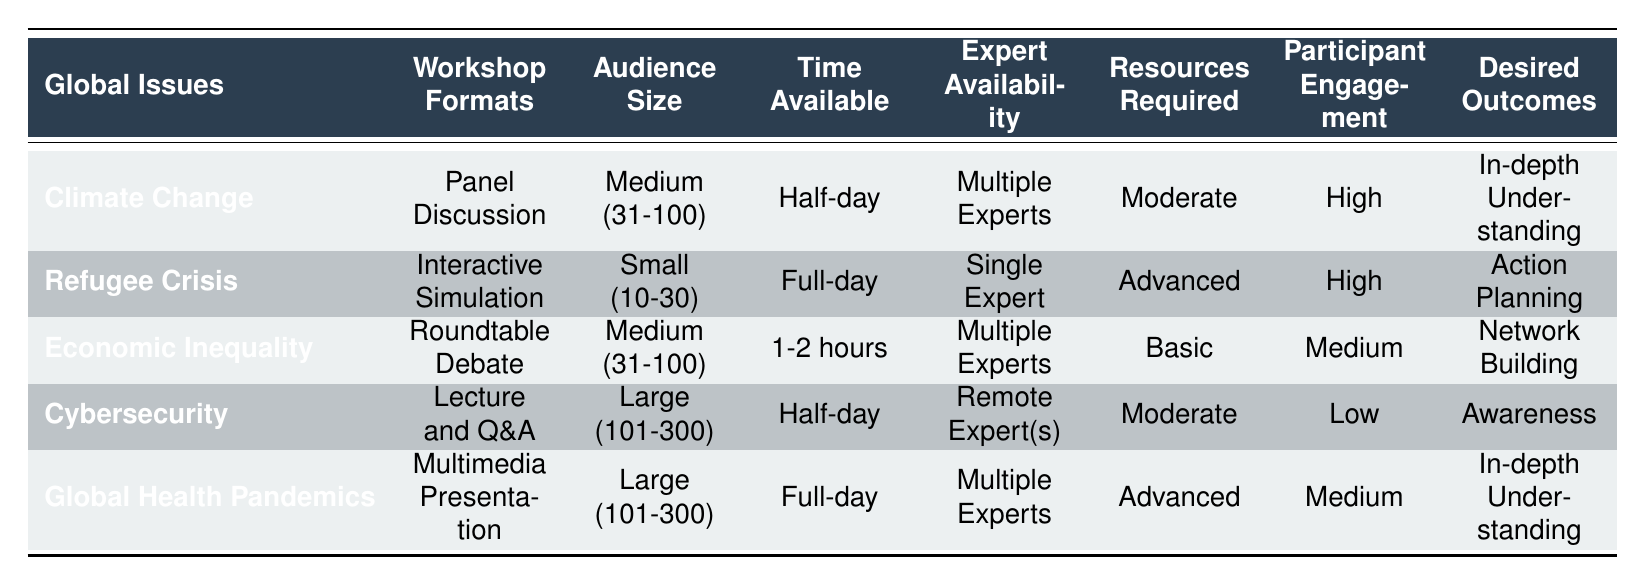What workshop format is recommended for addressing the Climate Change issue? The table indicates that the recommended workshop format for Climate Change is a Panel Discussion. This is found in the first row under the corresponding topic.
Answer: Panel Discussion Is the audience size for the Refugee Crisis workshop small, medium, or large? The Refugee Crisis workshop is designed for a small audience size, as noted in the table where it specifies "Small (10-30)" in the Audience Size column for this issue.
Answer: Small (10-30) Which global issue utilizes multiple experts and requires high participant engagement? By analyzing the rows, both Climate Change and Global Health Pandemics utilize multiple experts and have high participant engagement levels. The corresponding issues are Climate Change in the first row and Global Health Pandemics in the last row.
Answer: Climate Change and Global Health Pandemics Is the format for the Cybersecurity workshop an interactive simulation? The table states that the format for the Cybersecurity workshop is "Lecture and Q&A," which is a different type than an interactive simulation. This information can be directly checked in the row corresponding to Cybersecurity.
Answer: No What is the average expected audience size for workshops focused on Economic Inequality and Global Health Pandemics? The average audience size can be calculated by taking the audience sizes for Economic Inequality (Medium - 31-100) and Global Health Pandemics (Large - 101-300). We can convert "Medium" to an average of 65.5 and "Large" to an average of 200. Adding these yields 265. Dividing by 2 for the average gives us 132.5. Therefore, the average audience size for these two workshops is approximately 132.5.
Answer: 132.5 What are the desired outcomes for workshops on Economic Inequality and Cybersecurity? The desired outcome for Economic Inequality is "Network Building," while for Cybersecurity, it is "Awareness." This information can be extracted directly from their respective rows in the table.
Answer: Network Building and Awareness Does the Global Health Pandemics workshop require advanced resources? The table shows that the Global Health Pandemics workshop requires advanced resources, as noted in the Resources Required column where it specifies "Advanced (VR equipment, specialized software)." This is clearly stated in the row for Global Health Pandemics.
Answer: Yes For which global issue does the workshop format prioritize awareness as a desired outcome? The Cybersecurity workshop is the only one that prioritizes awareness, as indicated in its designated row in the desired outcomes column. Hence, Cybersecurity is directly related to the desired outcome of awareness.
Answer: Cybersecurity 